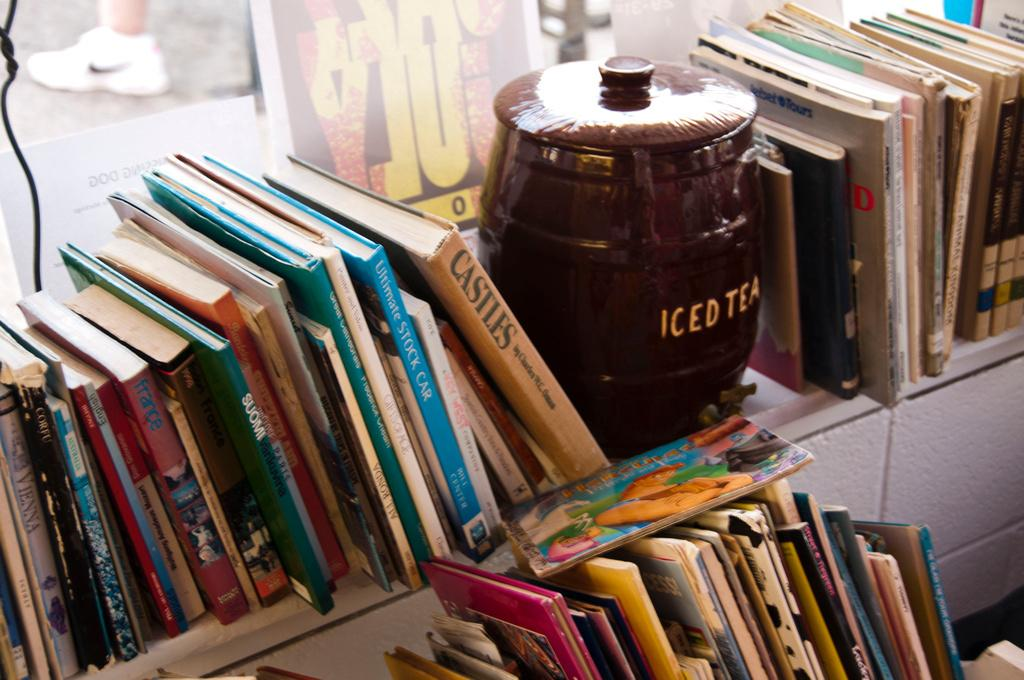<image>
Offer a succinct explanation of the picture presented. An iced tea container surrounded by a bunch of books including castles. 